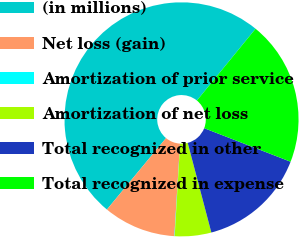<chart> <loc_0><loc_0><loc_500><loc_500><pie_chart><fcel>(in millions)<fcel>Net loss (gain)<fcel>Amortization of prior service<fcel>Amortization of net loss<fcel>Total recognized in other<fcel>Total recognized in expense<nl><fcel>49.9%<fcel>10.02%<fcel>0.05%<fcel>5.03%<fcel>15.0%<fcel>19.99%<nl></chart> 